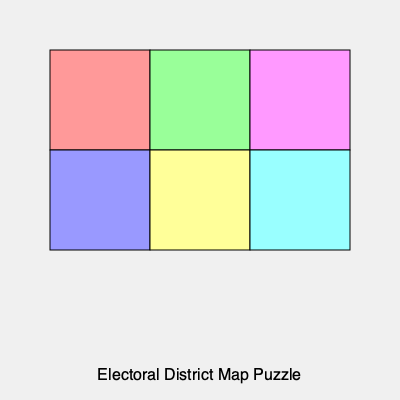As a political science graduate, you are tasked with reconstructing an electoral district map. The map is divided into six equal-sized square pieces, each representing a different district. If the total population of the state is 600,000 and each district must have an equal population, how many people should be in each district to ensure fair representation? To solve this problem, we need to follow these steps:

1. Understand the given information:
   - The map is divided into six equal-sized square pieces.
   - Each piece represents a different district.
   - The total population of the state is 600,000.
   - Each district must have an equal population for fair representation.

2. Calculate the population per district:
   - Total population: 600,000
   - Number of districts: 6
   - Population per district = Total population ÷ Number of districts
   - Population per district = 600,000 ÷ 6
   - Population per district = 100,000

3. Verify the result:
   - If each district has 100,000 people, then:
     100,000 × 6 = 600,000 (which matches the total population)

Therefore, to ensure fair representation, each district should have a population of 100,000 people.
Answer: 100,000 people per district 